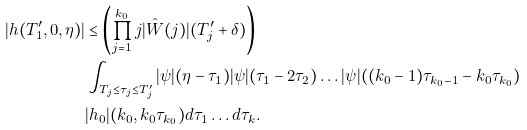Convert formula to latex. <formula><loc_0><loc_0><loc_500><loc_500>| h ( T _ { 1 } ^ { \prime } , 0 , \eta ) | & \leq \left ( \prod _ { j = 1 } ^ { k _ { 0 } } j | \hat { W } ( j ) | ( T _ { j } ^ { \prime } + \delta ) \right ) \\ & \int _ { T _ { j } \leq \tau _ { j } \leq T _ { j } ^ { \prime } } | \psi | ( \eta - \tau _ { 1 } ) | \psi | ( \tau _ { 1 } - 2 \tau _ { 2 } ) \dots | \psi | ( ( k _ { 0 } - 1 ) \tau _ { k _ { 0 } - 1 } - k _ { 0 } \tau _ { k _ { 0 } } ) \\ & | h _ { 0 } | ( k _ { 0 } , k _ { 0 } \tau _ { k _ { 0 } } ) d \tau _ { 1 } \dots d \tau _ { k } .</formula> 